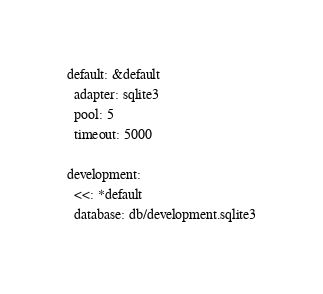<code> <loc_0><loc_0><loc_500><loc_500><_YAML_>default: &default
  adapter: sqlite3
  pool: 5
  timeout: 5000

development:
  <<: *default
  database: db/development.sqlite3</code> 